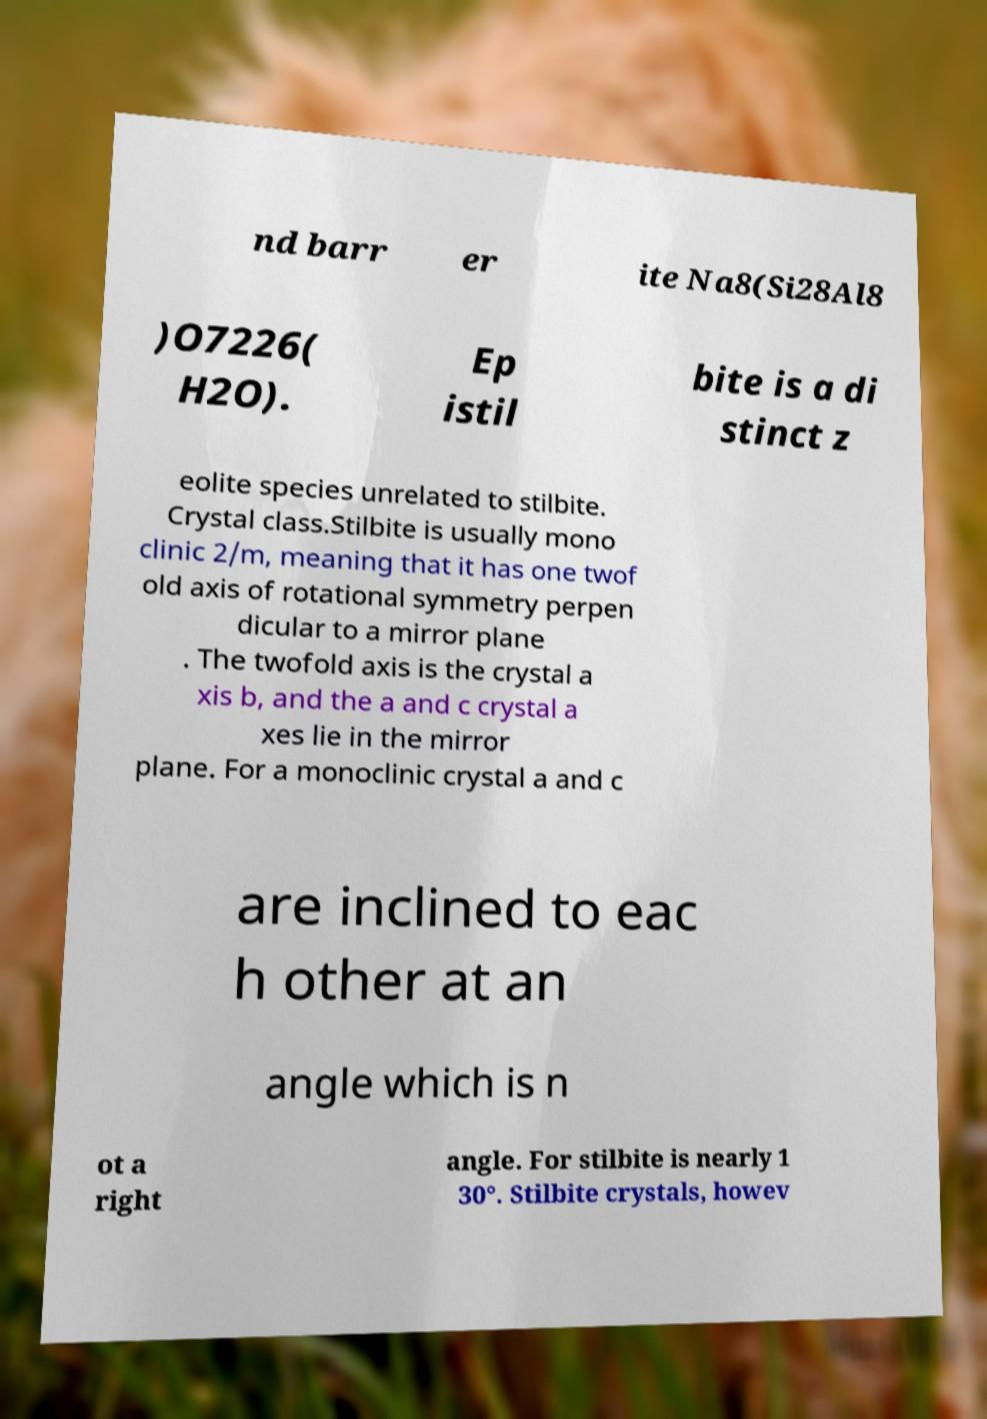Please identify and transcribe the text found in this image. nd barr er ite Na8(Si28Al8 )O7226( H2O). Ep istil bite is a di stinct z eolite species unrelated to stilbite. Crystal class.Stilbite is usually mono clinic 2/m, meaning that it has one twof old axis of rotational symmetry perpen dicular to a mirror plane . The twofold axis is the crystal a xis b, and the a and c crystal a xes lie in the mirror plane. For a monoclinic crystal a and c are inclined to eac h other at an angle which is n ot a right angle. For stilbite is nearly 1 30°. Stilbite crystals, howev 